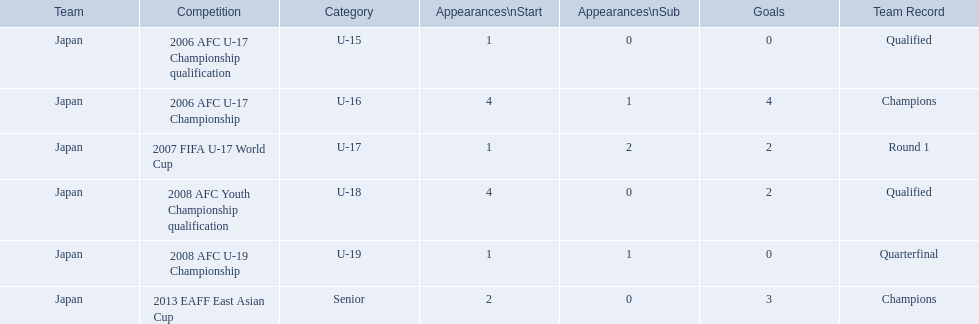What are all of the competitions? 2006 AFC U-17 Championship qualification, 2006 AFC U-17 Championship, 2007 FIFA U-17 World Cup, 2008 AFC Youth Championship qualification, 2008 AFC U-19 Championship, 2013 EAFF East Asian Cup. How many starting appearances were there? 1, 4, 1, 4, 1, 2. What about just during 2013 eaff east asian cup and 2007 fifa u-17 world cup? 1, 2. Which of those had more starting appearances? 2013 EAFF East Asian Cup. In which tournaments has yoichiro kakitani taken part? 2006 AFC U-17 Championship qualification, 2006 AFC U-17 Championship, 2007 FIFA U-17 World Cup, 2008 AFC Youth Championship qualification, 2008 AFC U-19 Championship, 2013 EAFF East Asian Cup. What was his starting count in each event? 1, 4, 1, 4, 1, 2. What was his goal tally in those contests? 0, 4, 2, 2, 0, 3. In which tournament did he have the most starts and goals? 2006 AFC U-17 Championship. In 2006, what was the record of the team? Round 1. Which competition was it a part of? 2006 AFC U-17 Championship. 